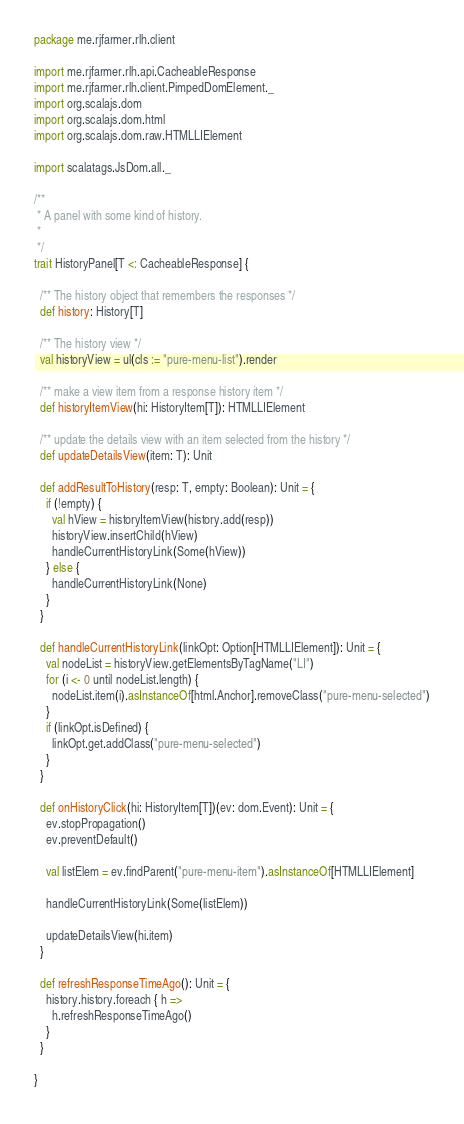Convert code to text. <code><loc_0><loc_0><loc_500><loc_500><_Scala_>package me.rjfarmer.rlh.client

import me.rjfarmer.rlh.api.CacheableResponse
import me.rjfarmer.rlh.client.PimpedDomElement._
import org.scalajs.dom
import org.scalajs.dom.html
import org.scalajs.dom.raw.HTMLLIElement

import scalatags.JsDom.all._

/**
 * A panel with some kind of history.
 *
 */
trait HistoryPanel[T <: CacheableResponse] {

  /** The history object that remembers the responses */
  def history: History[T]

  /** The history view */
  val historyView = ul(cls := "pure-menu-list").render

  /** make a view item from a response history item */
  def historyItemView(hi: HistoryItem[T]): HTMLLIElement

  /** update the details view with an item selected from the history */
  def updateDetailsView(item: T): Unit

  def addResultToHistory(resp: T, empty: Boolean): Unit = {
    if (!empty) {
      val hView = historyItemView(history.add(resp))
      historyView.insertChild(hView)
      handleCurrentHistoryLink(Some(hView))
    } else {
      handleCurrentHistoryLink(None)
    }
  }

  def handleCurrentHistoryLink(linkOpt: Option[HTMLLIElement]): Unit = {
    val nodeList = historyView.getElementsByTagName("LI")
    for (i <- 0 until nodeList.length) {
      nodeList.item(i).asInstanceOf[html.Anchor].removeClass("pure-menu-selected")
    }
    if (linkOpt.isDefined) {
      linkOpt.get.addClass("pure-menu-selected")
    }
  }

  def onHistoryClick(hi: HistoryItem[T])(ev: dom.Event): Unit = {
    ev.stopPropagation()
    ev.preventDefault()

    val listElem = ev.findParent("pure-menu-item").asInstanceOf[HTMLLIElement]

    handleCurrentHistoryLink(Some(listElem))

    updateDetailsView(hi.item)
  }

  def refreshResponseTimeAgo(): Unit = {
    history.history.foreach { h =>
      h.refreshResponseTimeAgo()
    }
  }

}
</code> 